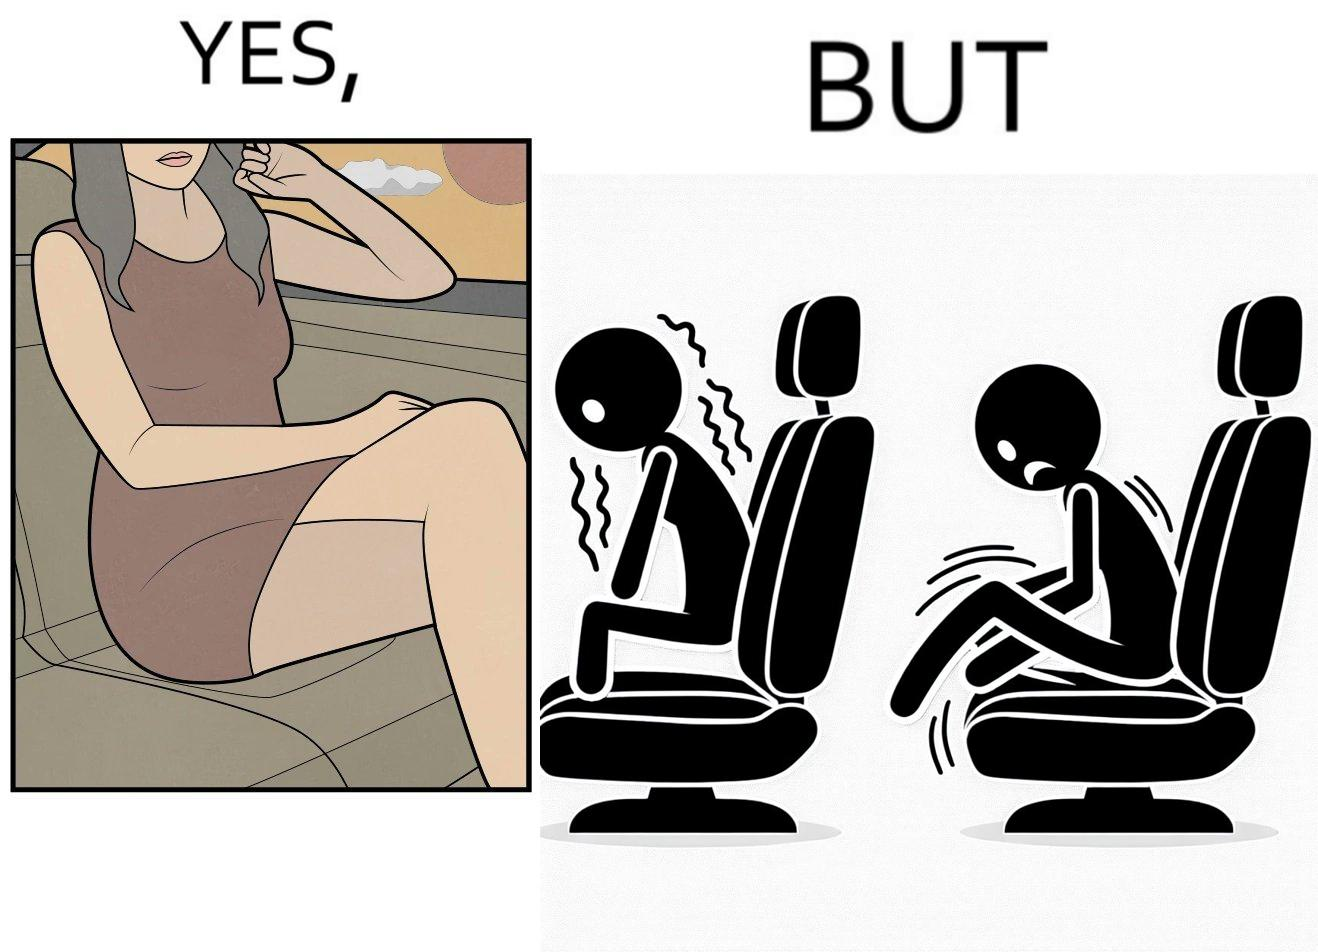Describe what you see in this image. The image is ironic, because the woman is wearing a short dress to look stylish but she had to face inconvenience while travelling in car due to her short dress only. 